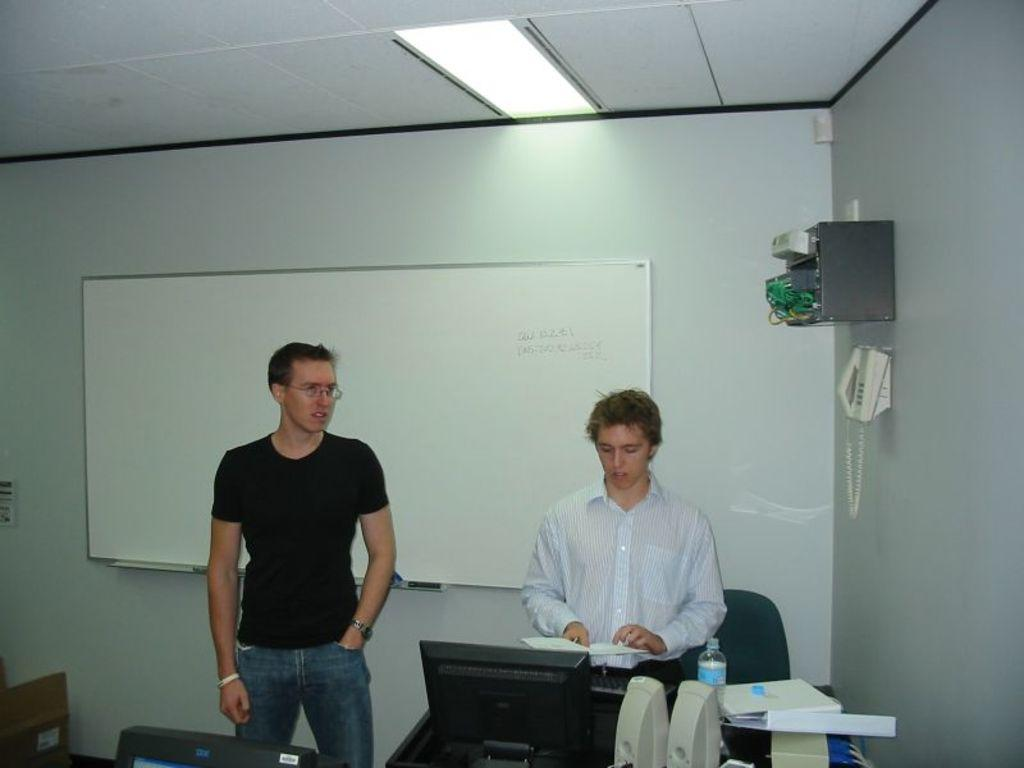How many people are present in the image? There are two men standing in the image. What is on the wall in the image? There is a whiteboard on a wall in the image. What type of needle can be seen in the image? There is no needle present in the image. How tall are the giants in the image? There are no giants present in the image. 